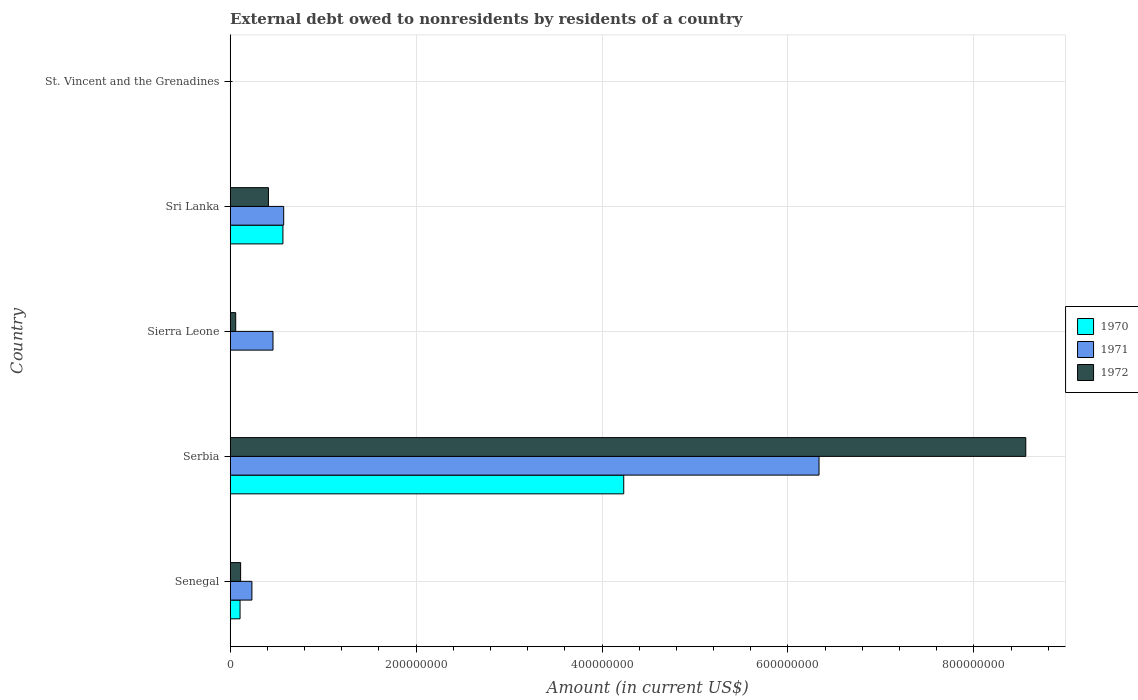How many groups of bars are there?
Your response must be concise. 5. Are the number of bars per tick equal to the number of legend labels?
Your response must be concise. No. How many bars are there on the 2nd tick from the top?
Your response must be concise. 3. What is the label of the 3rd group of bars from the top?
Give a very brief answer. Sierra Leone. What is the external debt owed by residents in 1970 in Sierra Leone?
Give a very brief answer. 0. Across all countries, what is the maximum external debt owed by residents in 1970?
Offer a very short reply. 4.23e+08. Across all countries, what is the minimum external debt owed by residents in 1971?
Make the answer very short. 3000. In which country was the external debt owed by residents in 1972 maximum?
Ensure brevity in your answer.  Serbia. What is the total external debt owed by residents in 1970 in the graph?
Give a very brief answer. 4.91e+08. What is the difference between the external debt owed by residents in 1971 in Senegal and that in Sierra Leone?
Make the answer very short. -2.27e+07. What is the difference between the external debt owed by residents in 1972 in Sierra Leone and the external debt owed by residents in 1970 in Senegal?
Make the answer very short. -4.66e+06. What is the average external debt owed by residents in 1972 per country?
Ensure brevity in your answer.  1.83e+08. What is the difference between the external debt owed by residents in 1972 and external debt owed by residents in 1970 in Serbia?
Provide a succinct answer. 4.32e+08. What is the ratio of the external debt owed by residents in 1972 in Sierra Leone to that in Sri Lanka?
Make the answer very short. 0.14. Is the difference between the external debt owed by residents in 1972 in Senegal and Sri Lanka greater than the difference between the external debt owed by residents in 1970 in Senegal and Sri Lanka?
Offer a terse response. Yes. What is the difference between the highest and the second highest external debt owed by residents in 1972?
Give a very brief answer. 8.15e+08. What is the difference between the highest and the lowest external debt owed by residents in 1971?
Offer a terse response. 6.33e+08. Is the sum of the external debt owed by residents in 1970 in Senegal and Sri Lanka greater than the maximum external debt owed by residents in 1971 across all countries?
Your answer should be very brief. No. Is it the case that in every country, the sum of the external debt owed by residents in 1972 and external debt owed by residents in 1970 is greater than the external debt owed by residents in 1971?
Provide a short and direct response. No. Are all the bars in the graph horizontal?
Your response must be concise. Yes. How many legend labels are there?
Offer a very short reply. 3. What is the title of the graph?
Give a very brief answer. External debt owed to nonresidents by residents of a country. Does "1983" appear as one of the legend labels in the graph?
Give a very brief answer. No. What is the label or title of the Y-axis?
Provide a succinct answer. Country. What is the Amount (in current US$) in 1970 in Senegal?
Offer a terse response. 1.06e+07. What is the Amount (in current US$) in 1971 in Senegal?
Provide a short and direct response. 2.34e+07. What is the Amount (in current US$) in 1972 in Senegal?
Offer a terse response. 1.12e+07. What is the Amount (in current US$) in 1970 in Serbia?
Your answer should be compact. 4.23e+08. What is the Amount (in current US$) in 1971 in Serbia?
Provide a succinct answer. 6.33e+08. What is the Amount (in current US$) of 1972 in Serbia?
Ensure brevity in your answer.  8.56e+08. What is the Amount (in current US$) in 1970 in Sierra Leone?
Provide a succinct answer. 0. What is the Amount (in current US$) of 1971 in Sierra Leone?
Provide a short and direct response. 4.61e+07. What is the Amount (in current US$) in 1972 in Sierra Leone?
Your response must be concise. 5.94e+06. What is the Amount (in current US$) of 1970 in Sri Lanka?
Your answer should be compact. 5.67e+07. What is the Amount (in current US$) in 1971 in Sri Lanka?
Provide a succinct answer. 5.76e+07. What is the Amount (in current US$) of 1972 in Sri Lanka?
Your answer should be compact. 4.12e+07. What is the Amount (in current US$) of 1970 in St. Vincent and the Grenadines?
Give a very brief answer. 3.60e+05. What is the Amount (in current US$) of 1971 in St. Vincent and the Grenadines?
Keep it short and to the point. 3000. What is the Amount (in current US$) of 1972 in St. Vincent and the Grenadines?
Offer a terse response. 1.50e+04. Across all countries, what is the maximum Amount (in current US$) of 1970?
Your answer should be compact. 4.23e+08. Across all countries, what is the maximum Amount (in current US$) of 1971?
Ensure brevity in your answer.  6.33e+08. Across all countries, what is the maximum Amount (in current US$) in 1972?
Offer a terse response. 8.56e+08. Across all countries, what is the minimum Amount (in current US$) of 1970?
Give a very brief answer. 0. Across all countries, what is the minimum Amount (in current US$) of 1971?
Offer a very short reply. 3000. Across all countries, what is the minimum Amount (in current US$) in 1972?
Ensure brevity in your answer.  1.50e+04. What is the total Amount (in current US$) in 1970 in the graph?
Ensure brevity in your answer.  4.91e+08. What is the total Amount (in current US$) of 1971 in the graph?
Your answer should be compact. 7.60e+08. What is the total Amount (in current US$) in 1972 in the graph?
Your answer should be very brief. 9.14e+08. What is the difference between the Amount (in current US$) in 1970 in Senegal and that in Serbia?
Give a very brief answer. -4.13e+08. What is the difference between the Amount (in current US$) of 1971 in Senegal and that in Serbia?
Make the answer very short. -6.10e+08. What is the difference between the Amount (in current US$) of 1972 in Senegal and that in Serbia?
Ensure brevity in your answer.  -8.45e+08. What is the difference between the Amount (in current US$) of 1971 in Senegal and that in Sierra Leone?
Offer a very short reply. -2.27e+07. What is the difference between the Amount (in current US$) of 1972 in Senegal and that in Sierra Leone?
Your answer should be compact. 5.29e+06. What is the difference between the Amount (in current US$) of 1970 in Senegal and that in Sri Lanka?
Make the answer very short. -4.61e+07. What is the difference between the Amount (in current US$) of 1971 in Senegal and that in Sri Lanka?
Give a very brief answer. -3.42e+07. What is the difference between the Amount (in current US$) in 1972 in Senegal and that in Sri Lanka?
Provide a succinct answer. -2.99e+07. What is the difference between the Amount (in current US$) in 1970 in Senegal and that in St. Vincent and the Grenadines?
Make the answer very short. 1.02e+07. What is the difference between the Amount (in current US$) of 1971 in Senegal and that in St. Vincent and the Grenadines?
Ensure brevity in your answer.  2.34e+07. What is the difference between the Amount (in current US$) of 1972 in Senegal and that in St. Vincent and the Grenadines?
Your response must be concise. 1.12e+07. What is the difference between the Amount (in current US$) in 1971 in Serbia and that in Sierra Leone?
Make the answer very short. 5.87e+08. What is the difference between the Amount (in current US$) of 1972 in Serbia and that in Sierra Leone?
Give a very brief answer. 8.50e+08. What is the difference between the Amount (in current US$) of 1970 in Serbia and that in Sri Lanka?
Give a very brief answer. 3.67e+08. What is the difference between the Amount (in current US$) of 1971 in Serbia and that in Sri Lanka?
Make the answer very short. 5.76e+08. What is the difference between the Amount (in current US$) of 1972 in Serbia and that in Sri Lanka?
Offer a very short reply. 8.15e+08. What is the difference between the Amount (in current US$) of 1970 in Serbia and that in St. Vincent and the Grenadines?
Offer a very short reply. 4.23e+08. What is the difference between the Amount (in current US$) in 1971 in Serbia and that in St. Vincent and the Grenadines?
Give a very brief answer. 6.33e+08. What is the difference between the Amount (in current US$) in 1972 in Serbia and that in St. Vincent and the Grenadines?
Offer a very short reply. 8.56e+08. What is the difference between the Amount (in current US$) in 1971 in Sierra Leone and that in Sri Lanka?
Provide a succinct answer. -1.15e+07. What is the difference between the Amount (in current US$) in 1972 in Sierra Leone and that in Sri Lanka?
Your response must be concise. -3.52e+07. What is the difference between the Amount (in current US$) of 1971 in Sierra Leone and that in St. Vincent and the Grenadines?
Your answer should be compact. 4.61e+07. What is the difference between the Amount (in current US$) in 1972 in Sierra Leone and that in St. Vincent and the Grenadines?
Give a very brief answer. 5.92e+06. What is the difference between the Amount (in current US$) in 1970 in Sri Lanka and that in St. Vincent and the Grenadines?
Keep it short and to the point. 5.64e+07. What is the difference between the Amount (in current US$) of 1971 in Sri Lanka and that in St. Vincent and the Grenadines?
Provide a succinct answer. 5.76e+07. What is the difference between the Amount (in current US$) of 1972 in Sri Lanka and that in St. Vincent and the Grenadines?
Your response must be concise. 4.11e+07. What is the difference between the Amount (in current US$) of 1970 in Senegal and the Amount (in current US$) of 1971 in Serbia?
Your answer should be compact. -6.23e+08. What is the difference between the Amount (in current US$) of 1970 in Senegal and the Amount (in current US$) of 1972 in Serbia?
Give a very brief answer. -8.45e+08. What is the difference between the Amount (in current US$) of 1971 in Senegal and the Amount (in current US$) of 1972 in Serbia?
Your response must be concise. -8.32e+08. What is the difference between the Amount (in current US$) in 1970 in Senegal and the Amount (in current US$) in 1971 in Sierra Leone?
Provide a short and direct response. -3.55e+07. What is the difference between the Amount (in current US$) of 1970 in Senegal and the Amount (in current US$) of 1972 in Sierra Leone?
Your answer should be compact. 4.66e+06. What is the difference between the Amount (in current US$) in 1971 in Senegal and the Amount (in current US$) in 1972 in Sierra Leone?
Ensure brevity in your answer.  1.74e+07. What is the difference between the Amount (in current US$) in 1970 in Senegal and the Amount (in current US$) in 1971 in Sri Lanka?
Provide a short and direct response. -4.70e+07. What is the difference between the Amount (in current US$) of 1970 in Senegal and the Amount (in current US$) of 1972 in Sri Lanka?
Give a very brief answer. -3.06e+07. What is the difference between the Amount (in current US$) in 1971 in Senegal and the Amount (in current US$) in 1972 in Sri Lanka?
Make the answer very short. -1.78e+07. What is the difference between the Amount (in current US$) of 1970 in Senegal and the Amount (in current US$) of 1971 in St. Vincent and the Grenadines?
Ensure brevity in your answer.  1.06e+07. What is the difference between the Amount (in current US$) of 1970 in Senegal and the Amount (in current US$) of 1972 in St. Vincent and the Grenadines?
Your response must be concise. 1.06e+07. What is the difference between the Amount (in current US$) in 1971 in Senegal and the Amount (in current US$) in 1972 in St. Vincent and the Grenadines?
Give a very brief answer. 2.34e+07. What is the difference between the Amount (in current US$) of 1970 in Serbia and the Amount (in current US$) of 1971 in Sierra Leone?
Provide a succinct answer. 3.77e+08. What is the difference between the Amount (in current US$) of 1970 in Serbia and the Amount (in current US$) of 1972 in Sierra Leone?
Provide a short and direct response. 4.17e+08. What is the difference between the Amount (in current US$) in 1971 in Serbia and the Amount (in current US$) in 1972 in Sierra Leone?
Keep it short and to the point. 6.28e+08. What is the difference between the Amount (in current US$) of 1970 in Serbia and the Amount (in current US$) of 1971 in Sri Lanka?
Offer a very short reply. 3.66e+08. What is the difference between the Amount (in current US$) of 1970 in Serbia and the Amount (in current US$) of 1972 in Sri Lanka?
Make the answer very short. 3.82e+08. What is the difference between the Amount (in current US$) in 1971 in Serbia and the Amount (in current US$) in 1972 in Sri Lanka?
Provide a short and direct response. 5.92e+08. What is the difference between the Amount (in current US$) in 1970 in Serbia and the Amount (in current US$) in 1971 in St. Vincent and the Grenadines?
Keep it short and to the point. 4.23e+08. What is the difference between the Amount (in current US$) of 1970 in Serbia and the Amount (in current US$) of 1972 in St. Vincent and the Grenadines?
Provide a short and direct response. 4.23e+08. What is the difference between the Amount (in current US$) in 1971 in Serbia and the Amount (in current US$) in 1972 in St. Vincent and the Grenadines?
Offer a very short reply. 6.33e+08. What is the difference between the Amount (in current US$) of 1971 in Sierra Leone and the Amount (in current US$) of 1972 in Sri Lanka?
Provide a short and direct response. 4.91e+06. What is the difference between the Amount (in current US$) in 1971 in Sierra Leone and the Amount (in current US$) in 1972 in St. Vincent and the Grenadines?
Your answer should be compact. 4.60e+07. What is the difference between the Amount (in current US$) in 1970 in Sri Lanka and the Amount (in current US$) in 1971 in St. Vincent and the Grenadines?
Your answer should be compact. 5.67e+07. What is the difference between the Amount (in current US$) in 1970 in Sri Lanka and the Amount (in current US$) in 1972 in St. Vincent and the Grenadines?
Your answer should be very brief. 5.67e+07. What is the difference between the Amount (in current US$) in 1971 in Sri Lanka and the Amount (in current US$) in 1972 in St. Vincent and the Grenadines?
Your response must be concise. 5.75e+07. What is the average Amount (in current US$) in 1970 per country?
Keep it short and to the point. 9.82e+07. What is the average Amount (in current US$) in 1971 per country?
Your answer should be compact. 1.52e+08. What is the average Amount (in current US$) of 1972 per country?
Offer a very short reply. 1.83e+08. What is the difference between the Amount (in current US$) in 1970 and Amount (in current US$) in 1971 in Senegal?
Keep it short and to the point. -1.28e+07. What is the difference between the Amount (in current US$) in 1970 and Amount (in current US$) in 1972 in Senegal?
Provide a short and direct response. -6.30e+05. What is the difference between the Amount (in current US$) in 1971 and Amount (in current US$) in 1972 in Senegal?
Provide a short and direct response. 1.21e+07. What is the difference between the Amount (in current US$) of 1970 and Amount (in current US$) of 1971 in Serbia?
Offer a terse response. -2.10e+08. What is the difference between the Amount (in current US$) of 1970 and Amount (in current US$) of 1972 in Serbia?
Your answer should be compact. -4.32e+08. What is the difference between the Amount (in current US$) of 1971 and Amount (in current US$) of 1972 in Serbia?
Ensure brevity in your answer.  -2.22e+08. What is the difference between the Amount (in current US$) in 1971 and Amount (in current US$) in 1972 in Sierra Leone?
Your response must be concise. 4.01e+07. What is the difference between the Amount (in current US$) of 1970 and Amount (in current US$) of 1971 in Sri Lanka?
Your answer should be very brief. -8.21e+05. What is the difference between the Amount (in current US$) in 1970 and Amount (in current US$) in 1972 in Sri Lanka?
Ensure brevity in your answer.  1.56e+07. What is the difference between the Amount (in current US$) in 1971 and Amount (in current US$) in 1972 in Sri Lanka?
Make the answer very short. 1.64e+07. What is the difference between the Amount (in current US$) of 1970 and Amount (in current US$) of 1971 in St. Vincent and the Grenadines?
Offer a very short reply. 3.57e+05. What is the difference between the Amount (in current US$) of 1970 and Amount (in current US$) of 1972 in St. Vincent and the Grenadines?
Ensure brevity in your answer.  3.45e+05. What is the difference between the Amount (in current US$) of 1971 and Amount (in current US$) of 1972 in St. Vincent and the Grenadines?
Your answer should be compact. -1.20e+04. What is the ratio of the Amount (in current US$) of 1970 in Senegal to that in Serbia?
Give a very brief answer. 0.03. What is the ratio of the Amount (in current US$) in 1971 in Senegal to that in Serbia?
Ensure brevity in your answer.  0.04. What is the ratio of the Amount (in current US$) of 1972 in Senegal to that in Serbia?
Keep it short and to the point. 0.01. What is the ratio of the Amount (in current US$) of 1971 in Senegal to that in Sierra Leone?
Your answer should be very brief. 0.51. What is the ratio of the Amount (in current US$) in 1972 in Senegal to that in Sierra Leone?
Make the answer very short. 1.89. What is the ratio of the Amount (in current US$) in 1970 in Senegal to that in Sri Lanka?
Provide a short and direct response. 0.19. What is the ratio of the Amount (in current US$) in 1971 in Senegal to that in Sri Lanka?
Your answer should be compact. 0.41. What is the ratio of the Amount (in current US$) of 1972 in Senegal to that in Sri Lanka?
Ensure brevity in your answer.  0.27. What is the ratio of the Amount (in current US$) in 1970 in Senegal to that in St. Vincent and the Grenadines?
Make the answer very short. 29.45. What is the ratio of the Amount (in current US$) of 1971 in Senegal to that in St. Vincent and the Grenadines?
Your response must be concise. 7789.33. What is the ratio of the Amount (in current US$) in 1972 in Senegal to that in St. Vincent and the Grenadines?
Make the answer very short. 748.73. What is the ratio of the Amount (in current US$) in 1971 in Serbia to that in Sierra Leone?
Provide a succinct answer. 13.75. What is the ratio of the Amount (in current US$) of 1972 in Serbia to that in Sierra Leone?
Provide a succinct answer. 144.15. What is the ratio of the Amount (in current US$) of 1970 in Serbia to that in Sri Lanka?
Your answer should be very brief. 7.46. What is the ratio of the Amount (in current US$) in 1971 in Serbia to that in Sri Lanka?
Keep it short and to the point. 11.01. What is the ratio of the Amount (in current US$) in 1972 in Serbia to that in Sri Lanka?
Make the answer very short. 20.8. What is the ratio of the Amount (in current US$) in 1970 in Serbia to that in St. Vincent and the Grenadines?
Give a very brief answer. 1175.96. What is the ratio of the Amount (in current US$) of 1971 in Serbia to that in St. Vincent and the Grenadines?
Your answer should be very brief. 2.11e+05. What is the ratio of the Amount (in current US$) of 1972 in Serbia to that in St. Vincent and the Grenadines?
Make the answer very short. 5.71e+04. What is the ratio of the Amount (in current US$) in 1971 in Sierra Leone to that in Sri Lanka?
Keep it short and to the point. 0.8. What is the ratio of the Amount (in current US$) of 1972 in Sierra Leone to that in Sri Lanka?
Provide a short and direct response. 0.14. What is the ratio of the Amount (in current US$) in 1971 in Sierra Leone to that in St. Vincent and the Grenadines?
Your answer should be compact. 1.54e+04. What is the ratio of the Amount (in current US$) in 1972 in Sierra Leone to that in St. Vincent and the Grenadines?
Make the answer very short. 395.8. What is the ratio of the Amount (in current US$) in 1970 in Sri Lanka to that in St. Vincent and the Grenadines?
Your answer should be compact. 157.59. What is the ratio of the Amount (in current US$) in 1971 in Sri Lanka to that in St. Vincent and the Grenadines?
Provide a succinct answer. 1.92e+04. What is the ratio of the Amount (in current US$) in 1972 in Sri Lanka to that in St. Vincent and the Grenadines?
Your answer should be very brief. 2743.4. What is the difference between the highest and the second highest Amount (in current US$) in 1970?
Provide a succinct answer. 3.67e+08. What is the difference between the highest and the second highest Amount (in current US$) in 1971?
Ensure brevity in your answer.  5.76e+08. What is the difference between the highest and the second highest Amount (in current US$) of 1972?
Your answer should be compact. 8.15e+08. What is the difference between the highest and the lowest Amount (in current US$) of 1970?
Provide a succinct answer. 4.23e+08. What is the difference between the highest and the lowest Amount (in current US$) in 1971?
Offer a terse response. 6.33e+08. What is the difference between the highest and the lowest Amount (in current US$) of 1972?
Your answer should be very brief. 8.56e+08. 